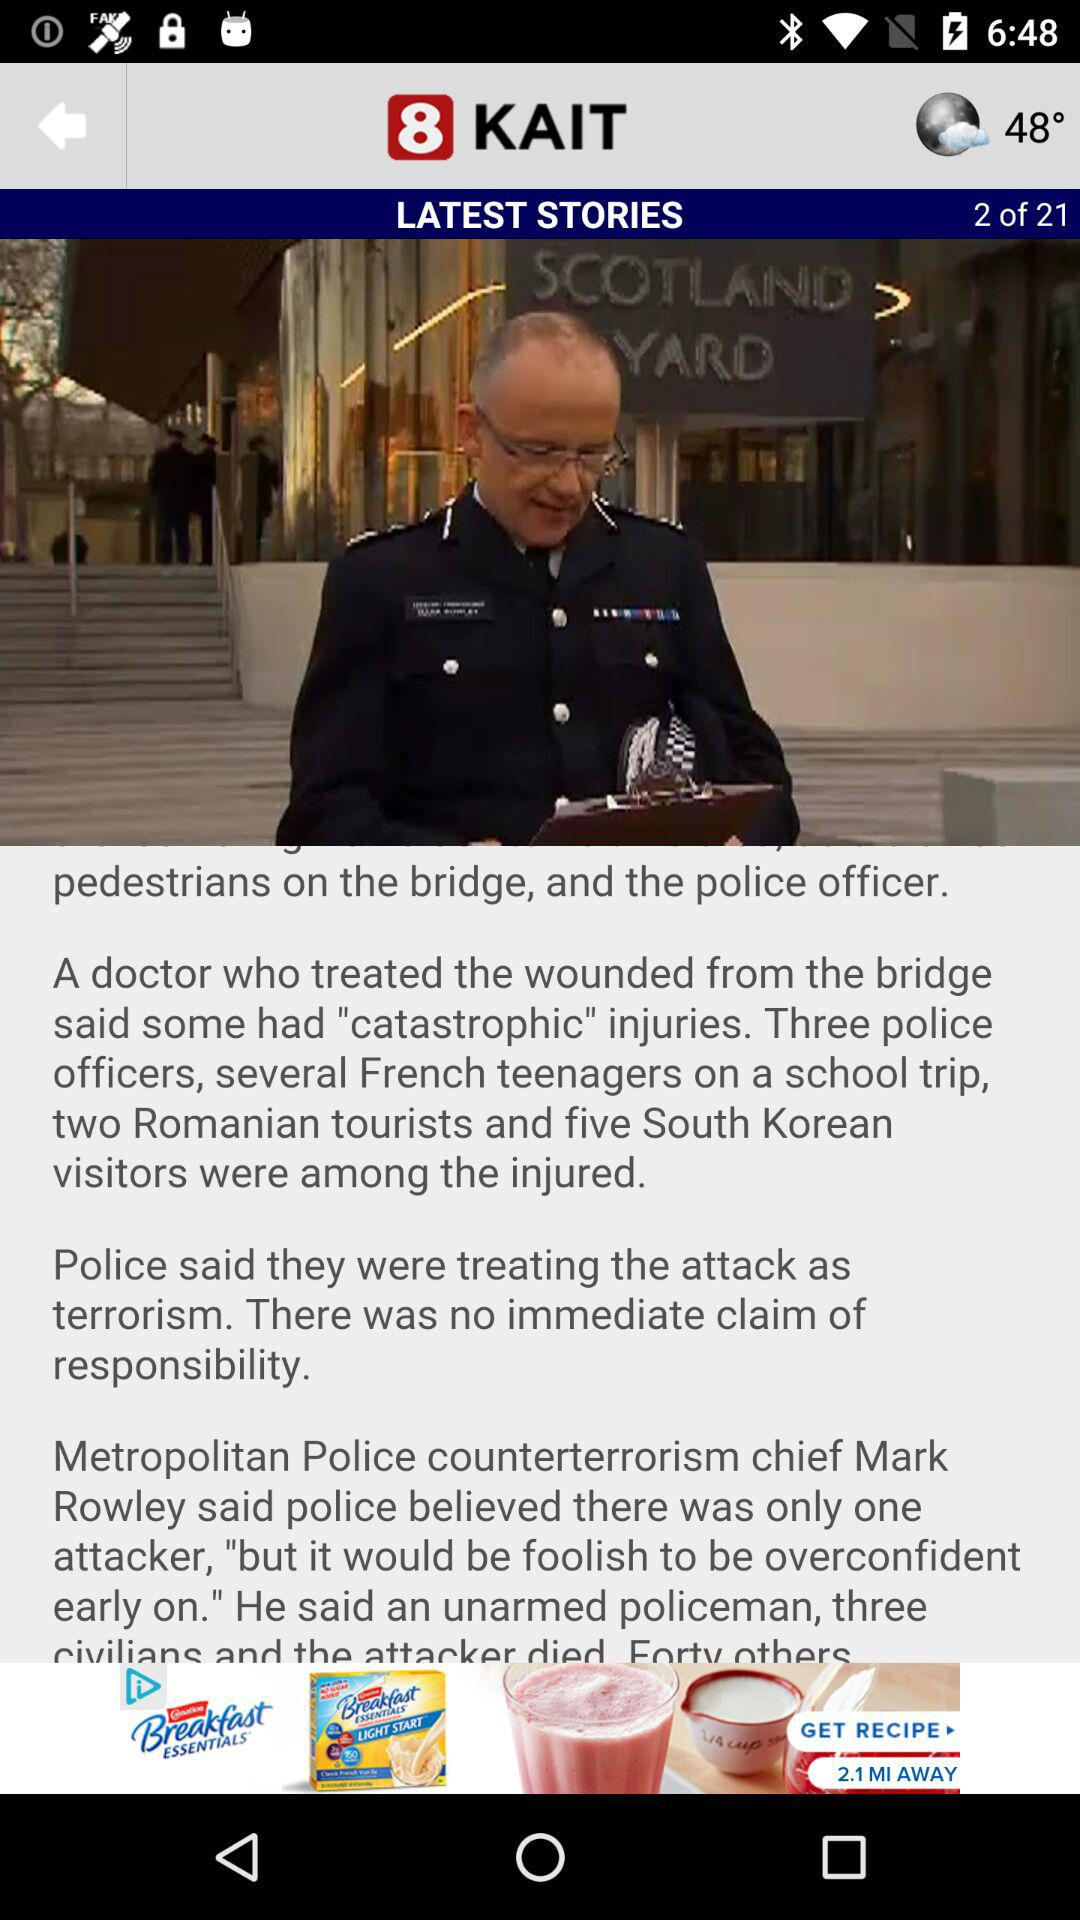What is the total number of the latest stories? There are 21 latest stories. 